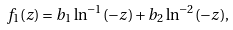Convert formula to latex. <formula><loc_0><loc_0><loc_500><loc_500>f _ { 1 } ( z ) = b _ { 1 } \ln ^ { - 1 } ( - z ) + b _ { 2 } \ln ^ { - 2 } ( - z ) ,</formula> 